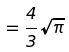Convert formula to latex. <formula><loc_0><loc_0><loc_500><loc_500>= \frac { 4 } { 3 } \sqrt { \pi }</formula> 